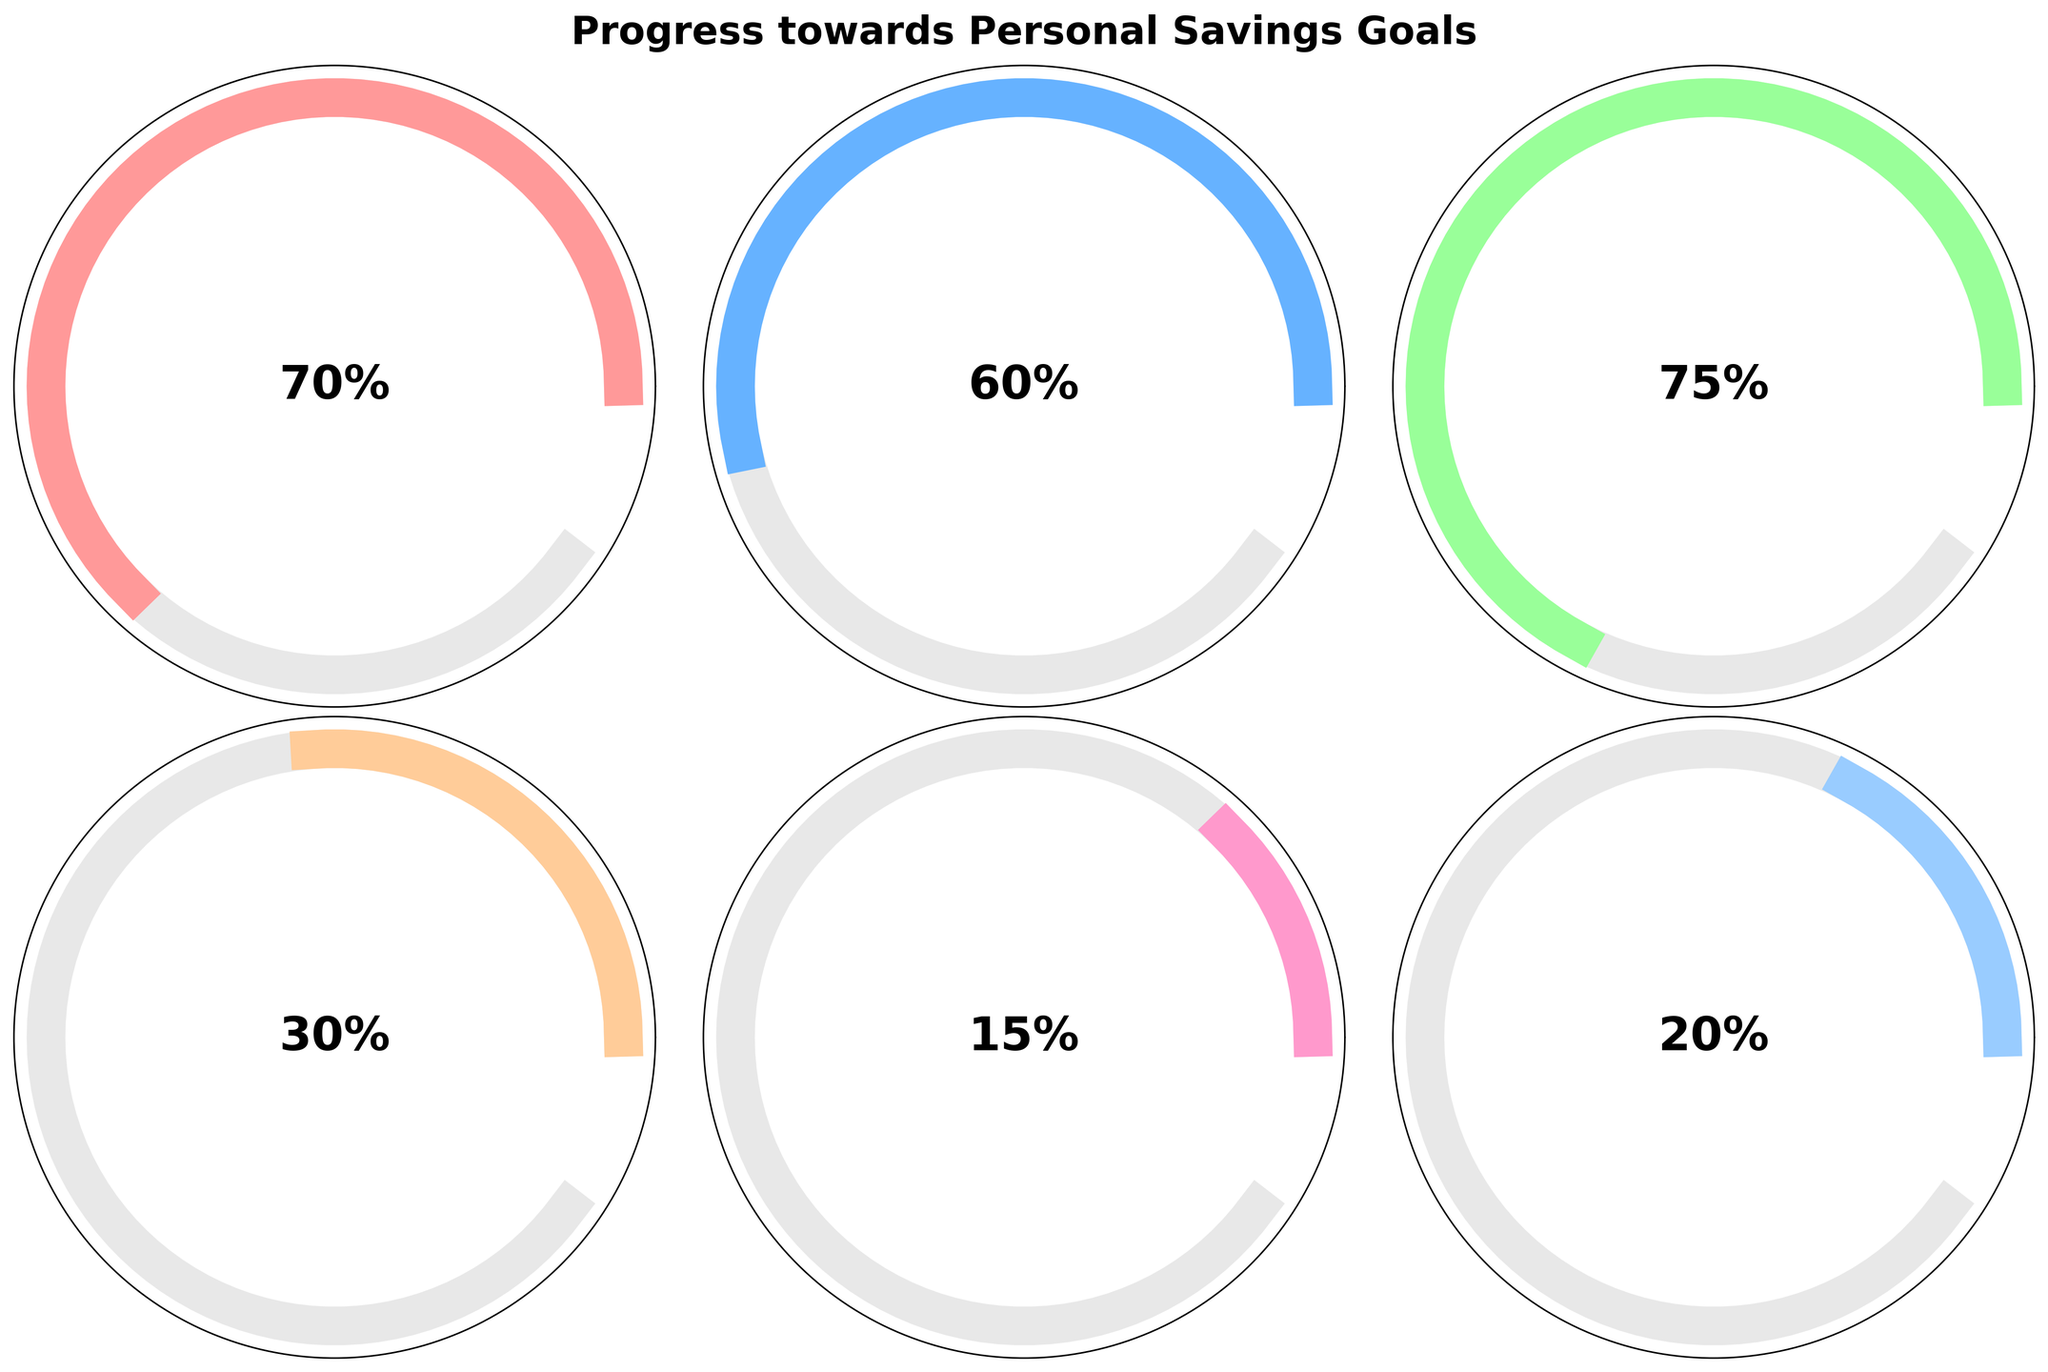What's the title of the figure? The title of the figure is written at the top of the image in a bold font. It can be read directly from the visual information provided in the figure.
Answer: Progress towards Personal Savings Goals Which category has the highest percentage completion? To find this, look for the gauge with the highest percentage displayed at the center. The short-term New Smartphone gauge shows 75%, which is the highest among all categories.
Answer: Short-term New Smartphone How much current progress has been made towards the Long-term Down Payment for House goal? The information about the current progress can be read directly from the gauge for the Long-term Down Payment for House. The gauge displays $15,000 as the current progress.
Answer: $15,000 Compare the progress percentage of the Short-term Vacation Savings and Long-term Children's College Fund. Which one has a higher percentage? Check the percentage displayed in the center of both gauges. Short-term Vacation Savings has 60%, while Long-term Children's College Fund has 20%. Since 60% is greater than 20%, Short-term Vacation Savings has a higher percentage.
Answer: Short-term Vacation Savings What is the total amount of the goals for the Long-term objectives? To get the total goal amount for Long-term objectives, sum up the goal amounts for Long-term Down Payment for House, Long-term Retirement Fund, and Long-term Children's College Fund. These are $50,000 + $500,000 + $100,000 respectively, which total to $650,000.
Answer: $650,000 Which category has the least amount of current progress? To find this, check the current progress displayed in monetary terms on all gauges. The Long-term Retirement Fund has $75,000 out of $500,000 which is 15%, the least among all categories.
Answer: Long-term Retirement Fund What's the difference in the goal amounts between the Short-term Emergency Fund and the Long-term Down Payment for House? The goal amount for the Short-term Emergency Fund is $5,000 and for the Long-term Down Payment for House is $50,000. The difference is calculated by subtracting $5,000 from $50,000, resulting in $45,000.
Answer: $45,000 Among the Long-term objectives, which has the lowest progress percentage? Look at the progress percentages displayed on the gauges for all Long-term objectives. The Long-term Retirement Fund has the lowest percentage completion at 15%.
Answer: Long-term Retirement Fund 